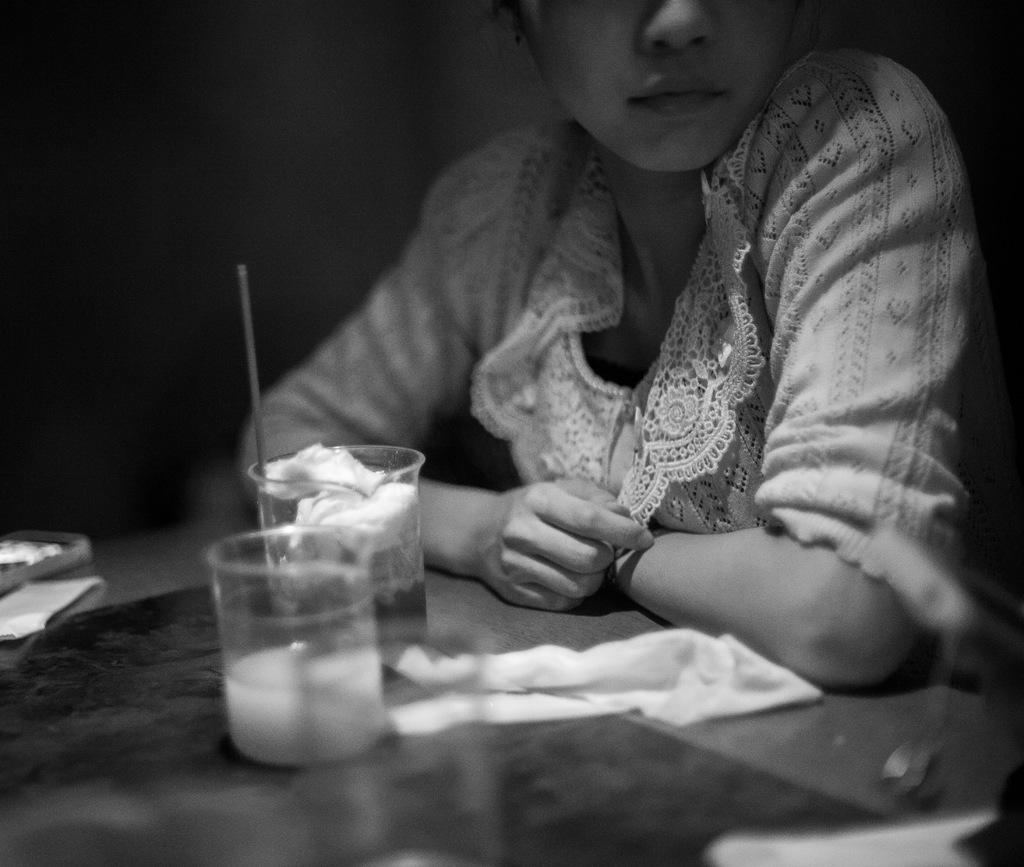What objects are on the table in the image? There are glasses and cloth on the table in the image. What else can be seen on the table? There are other objects on the table, but their specific details are not mentioned in the facts. Who is present near the table? There is a person beside the table in the image. How would you describe the lighting in the image? The background of the image is dark. What type of wealth is displayed on the table in the image? There is no indication of wealth in the image; it only shows glasses, cloth, and other unspecified objects on the table. What word is written on the cloth in the image? There is no word written on the cloth in the image; it is simply a piece of cloth on the table. 